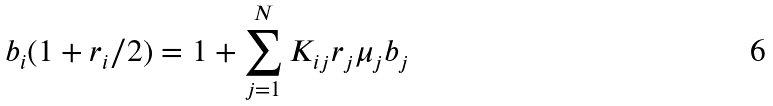<formula> <loc_0><loc_0><loc_500><loc_500>b _ { i } ( 1 + r _ { i } / 2 ) = 1 + \sum _ { j = 1 } ^ { N } K _ { i j } r _ { j } \mu _ { j } b _ { j }</formula> 